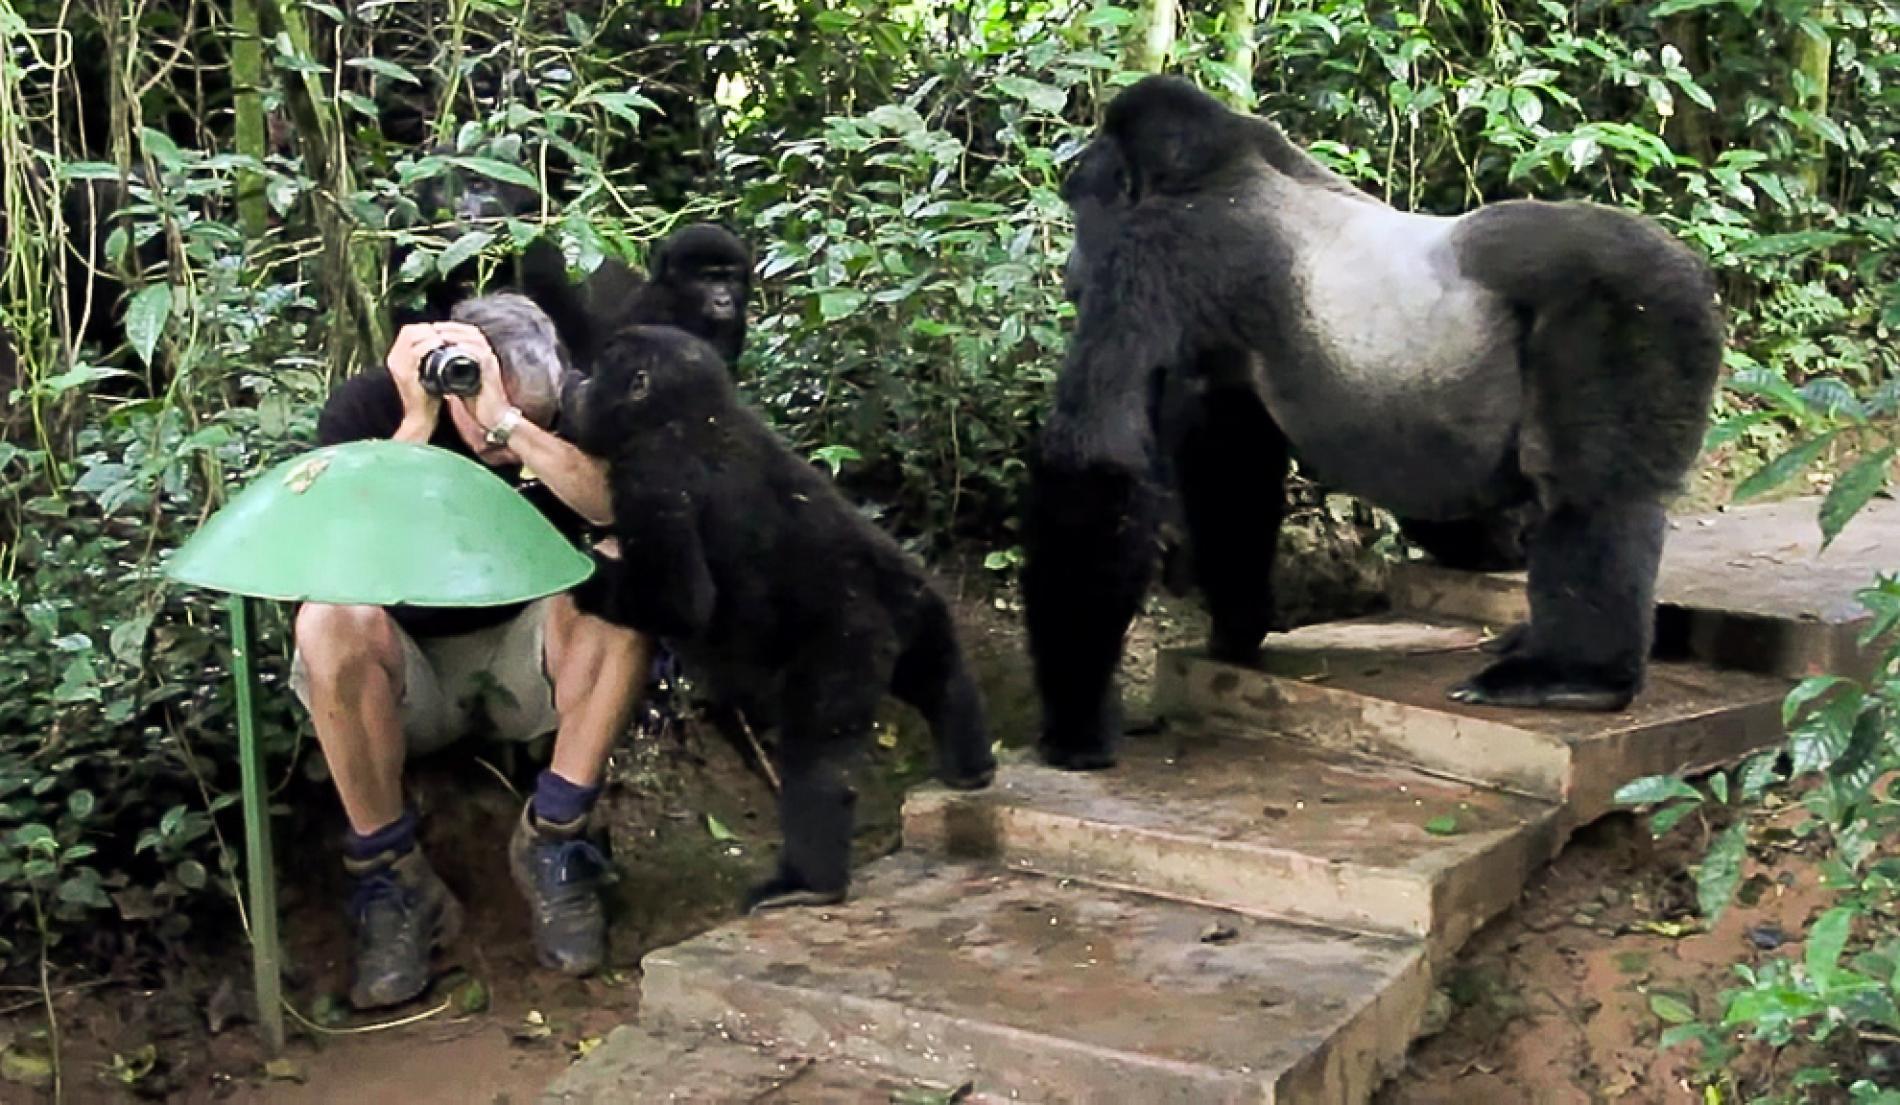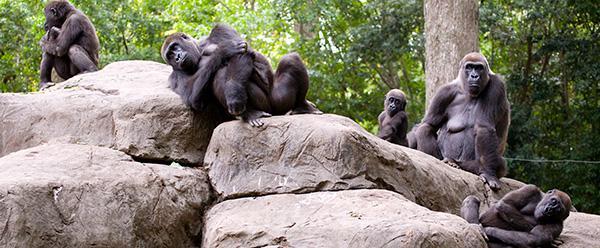The first image is the image on the left, the second image is the image on the right. For the images displayed, is the sentence "The left image contains a human interacting with a gorilla." factually correct? Answer yes or no. Yes. 